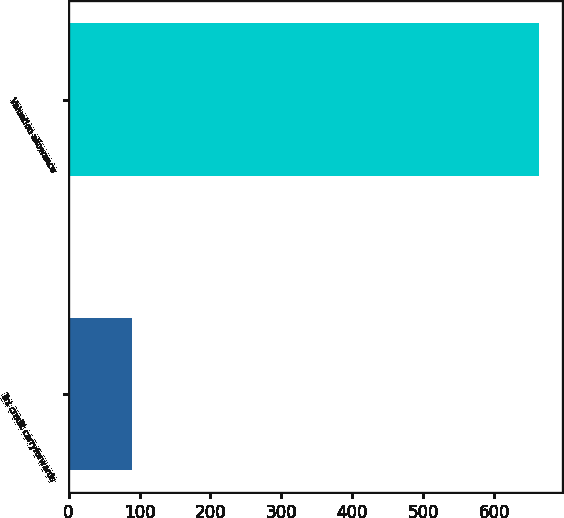Convert chart to OTSL. <chart><loc_0><loc_0><loc_500><loc_500><bar_chart><fcel>Tax credit carryforwards<fcel>Valuation allowance<nl><fcel>89<fcel>663<nl></chart> 